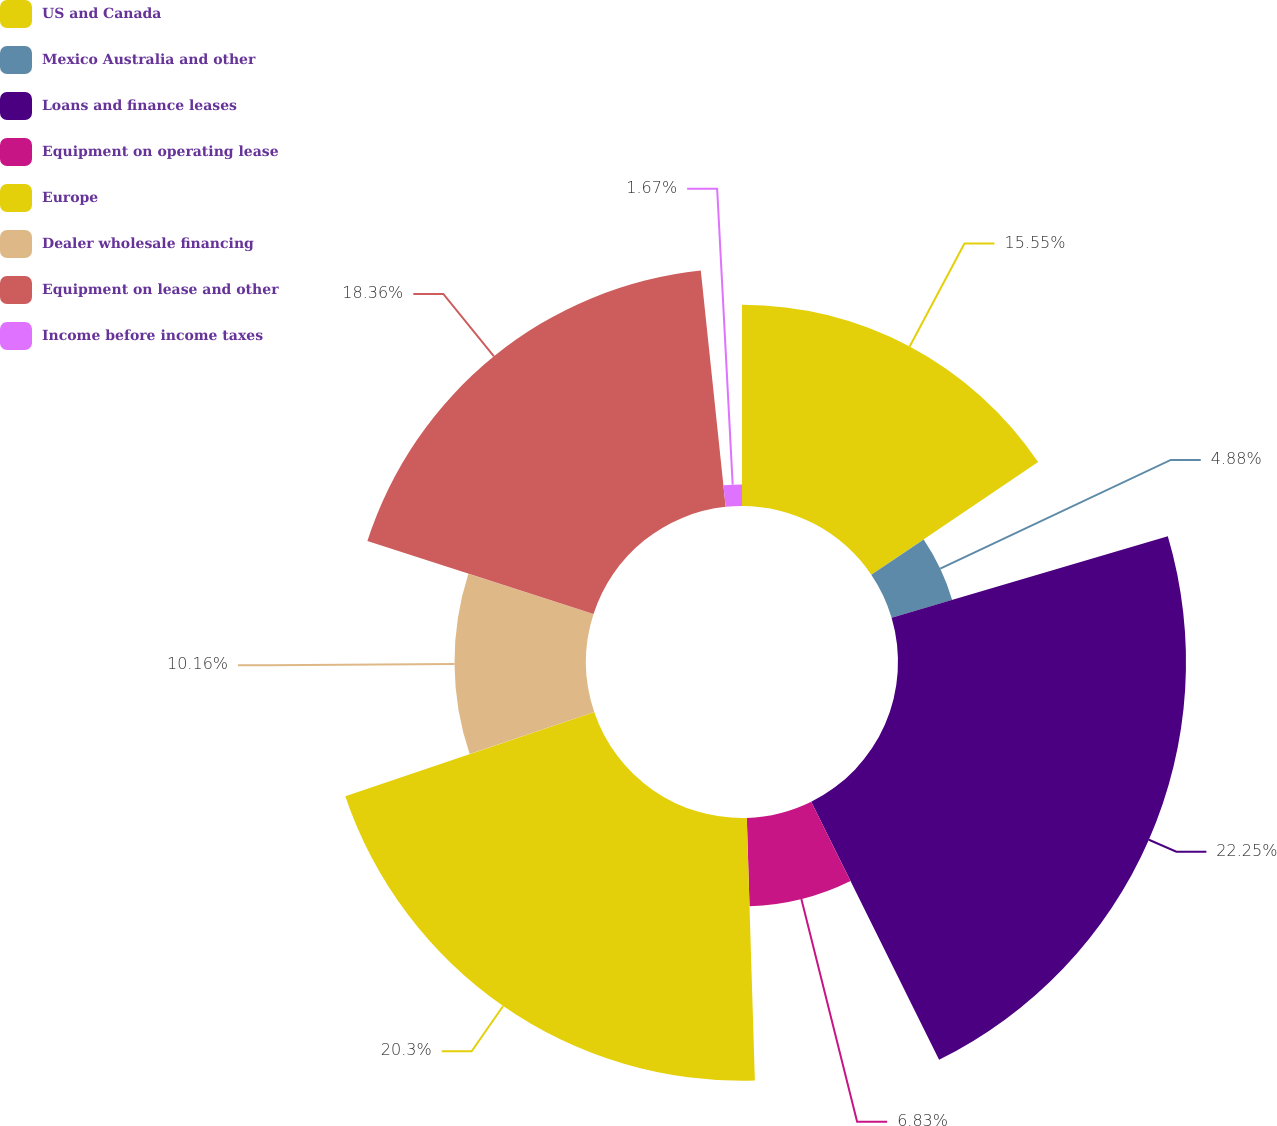Convert chart. <chart><loc_0><loc_0><loc_500><loc_500><pie_chart><fcel>US and Canada<fcel>Mexico Australia and other<fcel>Loans and finance leases<fcel>Equipment on operating lease<fcel>Europe<fcel>Dealer wholesale financing<fcel>Equipment on lease and other<fcel>Income before income taxes<nl><fcel>15.55%<fcel>4.88%<fcel>22.25%<fcel>6.83%<fcel>20.3%<fcel>10.16%<fcel>18.36%<fcel>1.67%<nl></chart> 